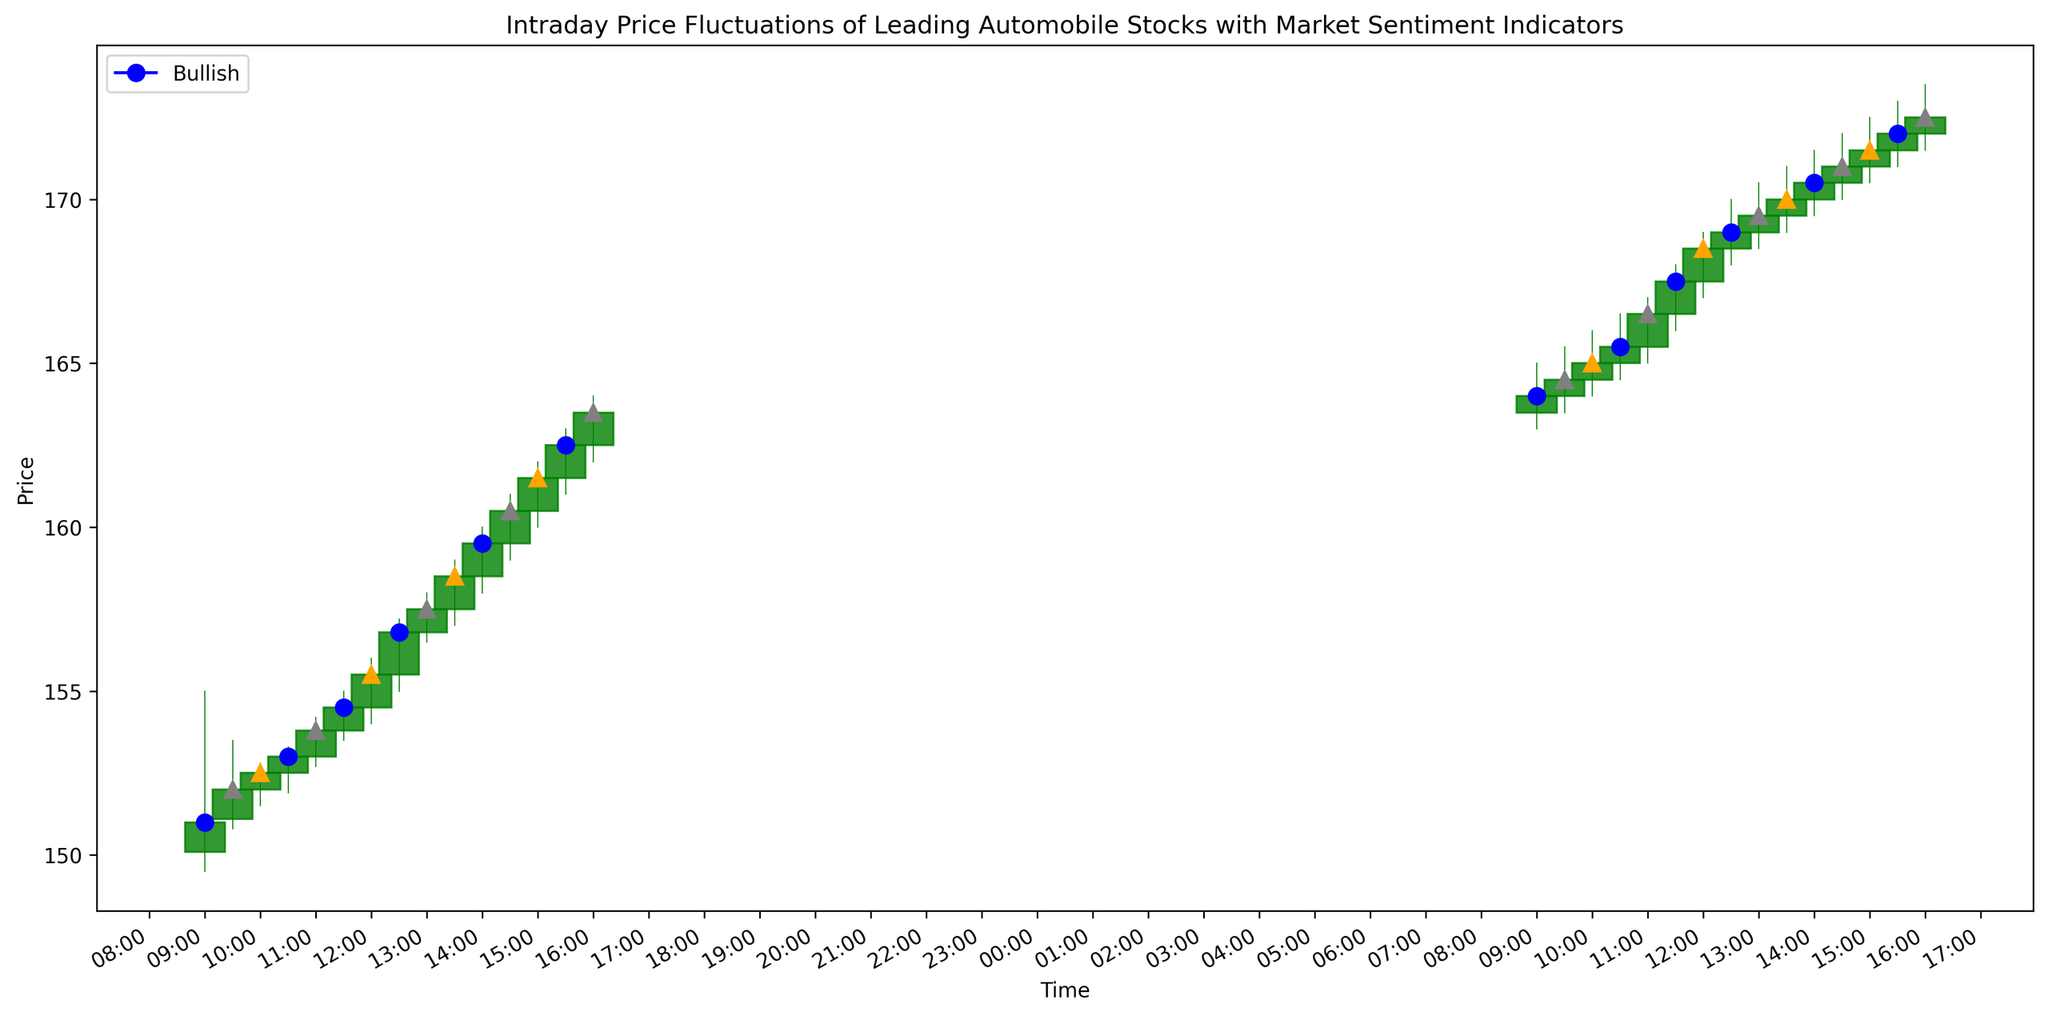What is the closing price at 10:00 on October 1st, 2023? Look for the candlestick corresponding to the 10:00 timestamp on October 1st. Identify the closing price by examining the top of the lower vertical line (or the bottom of the upper rectangular body) depending on the color of the candlestick.
Answer: 152.50 Between 09:00 and 16:00 on October 1st, 2023, how many times does the stock appear to have a Bullish sentiment based on the markers? Observe the markers along the candlesticks on October 1st and count the blue circles, which indicate a Bullish sentiment. There are 4 blue circle markers (09:00, 10:30, 11:30, 14:00).
Answer: 4 What is the highest price recorded on October 2nd, 2023? Identify the highest points of the upper wicks of the candlesticks from the 09:00 timestamp on October 2nd until the end of the day. The highest point is at 15:30 with a value of 173.00.
Answer: 173.00 Which date shows more robust intraday gains, October 1st or October 2nd, 2023? To determine this, calculate the difference between the closing price of the final candlestick and the opening price of the initial candlestick for each day. For October 1st, the difference is \(163.50 - 150.10 = 13.40\). For October 2nd, the difference is \(172.50 - 163.50 = 9.00\). October 1st shows more robust gains.
Answer: October 1st During which interval does the price exhibit the highest single candlestick gain on October 1st, 2023? Calculate the high-low difference for each candlestick and identify the one with the largest difference. The interval with the highest single candlestick gain on October 1st is from 09:00 to 09:30 where the high is 155.00 and the low is 149.50, resulting in a gain of 5.50.
Answer: 09:00 to 09:30 What is the predominant sentiment throughout October 2nd, 2023? Count the occurrences of each sentiment marker (Bullish, Bearish, and Neutral) on October 2nd. Bullish sentiment markers (blue circles) appear 4 times, Bearish sentiment occurs 3 times, and Neutral sentiment occurs 3 times. Therefore, Bullish is the predominant sentiment.
Answer: Bullish Compare the average closing price on October 1st, 2023, to October 2nd, 2023. Which day had the higher average closing price? Calculate the average closing price for each day. For October 1st: \((151.00 + 152.00 + 152.50 + 153.00 + 153.80 + 154.50 + 155.50 + 156.80 + 157.50 + 158.50 + 159.50 + 160.50 + 161.50 + 162.50 + 163.50)/15 = 156.30\). For October 2nd: \((164.00 + 164.50 + 165.00 + 165.50 + 166.50 + 167.50 + 168.50 + 169.00 + 169.50 + 170.00 + 170.50 + 171.00 + 171.50 + 172.00 + 172.50)/15 = 168.70\). October 2nd had the higher average closing price.
Answer: October 2nd Is there a specific time of day on October 1st and October 2nd where Neutral sentiment is more apparent? Check the candlesticks for both days and observe the distribution of gray markers indicating Neutral sentiment. On both days, Neutral sentiment appears at random intervals; therefore, no specific time of day shows a prominent pattern.
Answer: No specific time Which day experienced the most Bearish sentiment based on the closing prices and sentiment markers? Count the Bearish markers on each day and compare. October 1st has 4 Bearish markers and October 2nd has 3 Bearish markers. Therefore, October 1st experienced more Bearish sentiment.
Answer: October 1st 